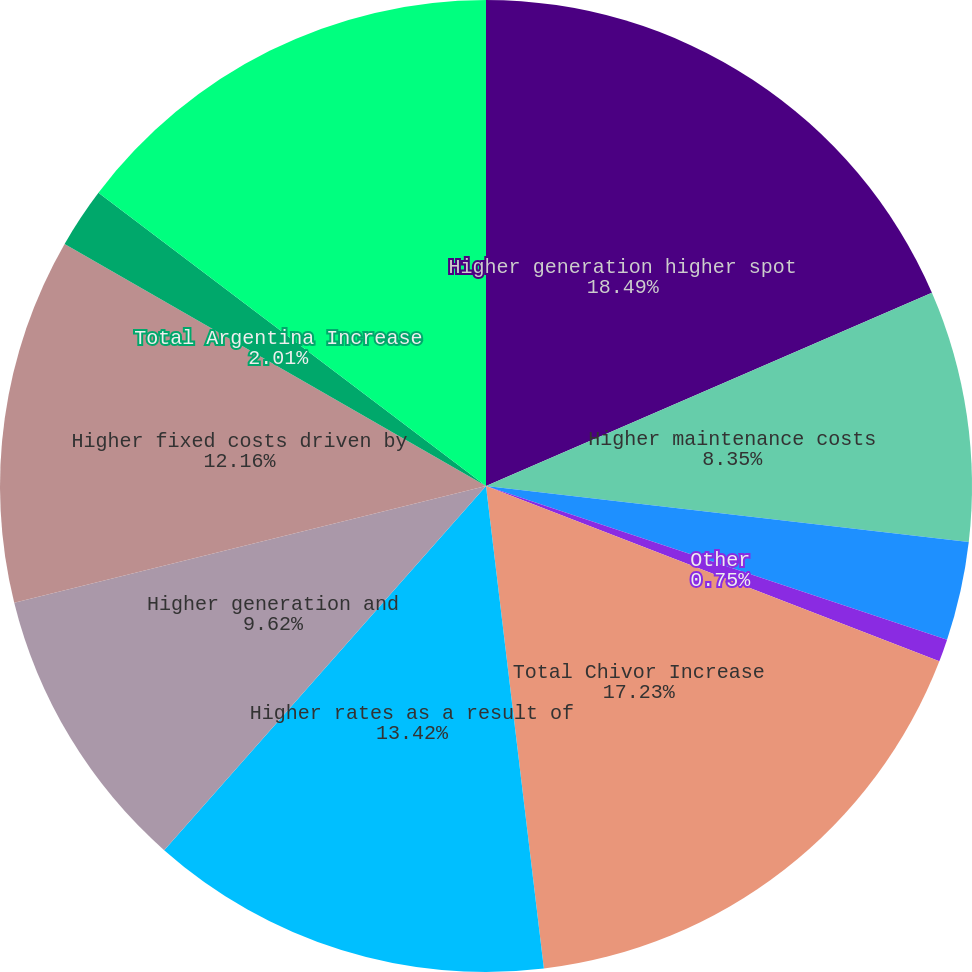Convert chart. <chart><loc_0><loc_0><loc_500><loc_500><pie_chart><fcel>Higher generation higher spot<fcel>Higher maintenance costs<fcel>Unfavorable FX impacts<fcel>Other<fcel>Total Chivor Increase<fcel>Higher rates as a result of<fcel>Higher generation and<fcel>Higher fixed costs driven by<fcel>Total Argentina Increase<fcel>Lower contract prices spot<nl><fcel>18.49%<fcel>8.35%<fcel>3.28%<fcel>0.75%<fcel>17.23%<fcel>13.42%<fcel>9.62%<fcel>12.16%<fcel>2.01%<fcel>14.69%<nl></chart> 